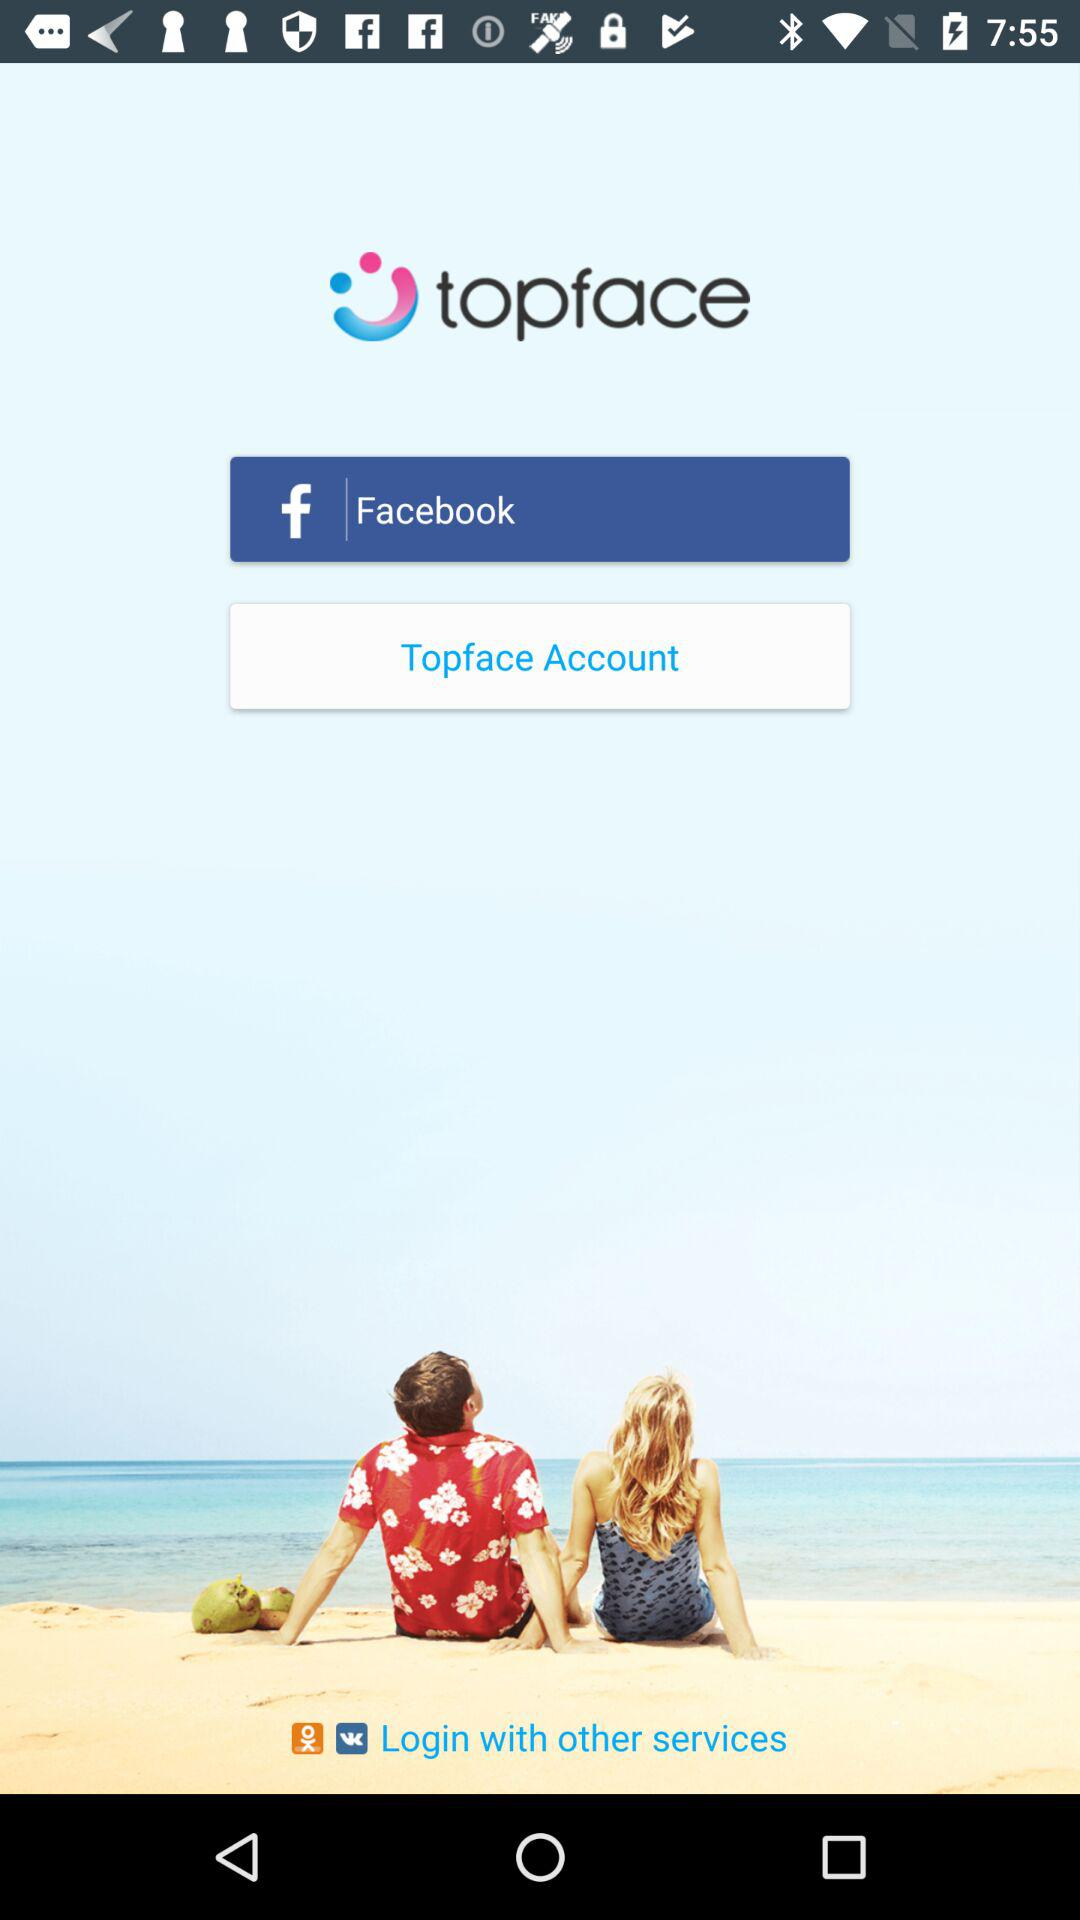What application can we use for login? You can login with Facebook. 